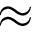<formula> <loc_0><loc_0><loc_500><loc_500>\approx</formula> 